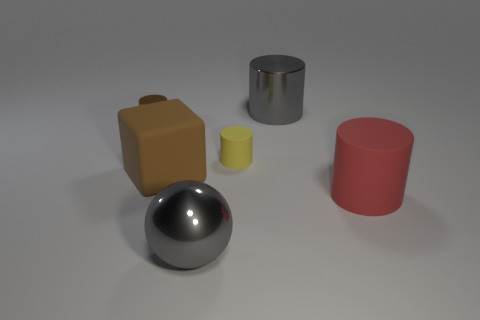Is the material of the big gray ball the same as the tiny yellow object?
Your answer should be compact. No. There is a matte cylinder left of the large matte thing that is right of the gray metallic sphere; what is its color?
Provide a succinct answer. Yellow. There is a red cylinder that is the same material as the small yellow thing; what size is it?
Provide a succinct answer. Large. What number of large red things are the same shape as the brown shiny thing?
Ensure brevity in your answer.  1. What number of things are brown things in front of the tiny yellow cylinder or metal cylinders behind the block?
Your answer should be compact. 3. How many matte cubes are to the right of the large red cylinder that is on the right side of the small rubber cylinder?
Ensure brevity in your answer.  0. Do the small thing behind the small yellow rubber cylinder and the big object that is to the right of the gray cylinder have the same shape?
Offer a terse response. Yes. What is the shape of the small object that is the same color as the big cube?
Give a very brief answer. Cylinder. Is there a red cylinder made of the same material as the big cube?
Provide a succinct answer. Yes. How many metal things are brown objects or yellow cylinders?
Your answer should be very brief. 1. 